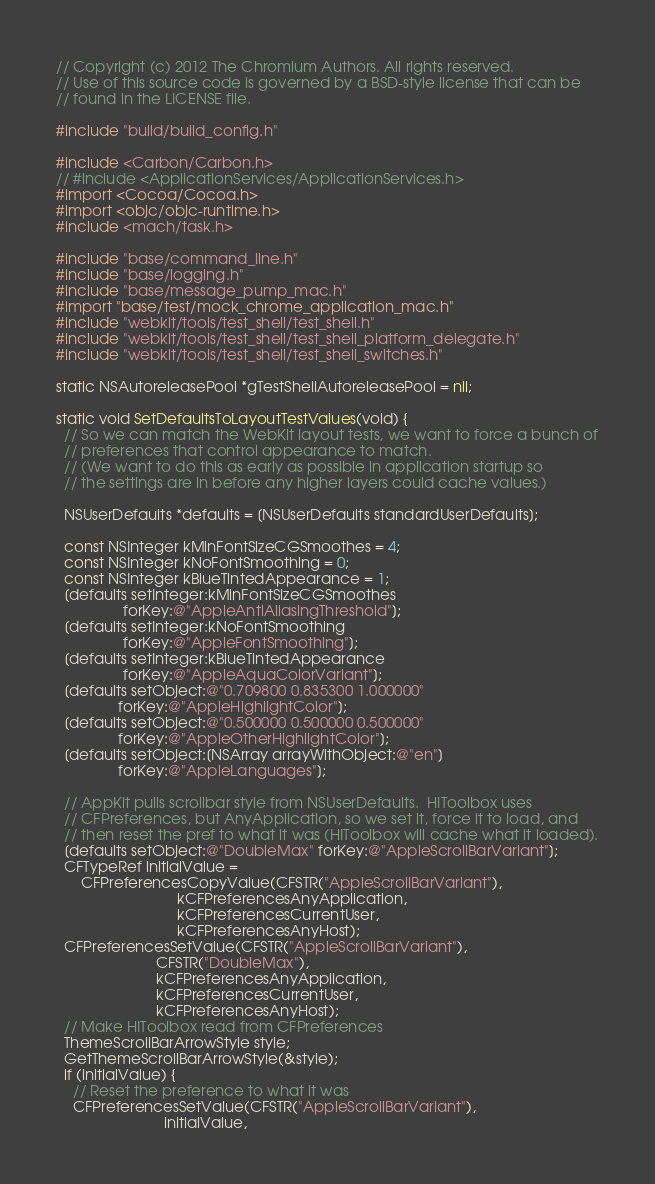<code> <loc_0><loc_0><loc_500><loc_500><_ObjectiveC_>// Copyright (c) 2012 The Chromium Authors. All rights reserved.
// Use of this source code is governed by a BSD-style license that can be
// found in the LICENSE file.

#include "build/build_config.h"

#include <Carbon/Carbon.h>
// #include <ApplicationServices/ApplicationServices.h>
#import <Cocoa/Cocoa.h>
#import <objc/objc-runtime.h>
#include <mach/task.h>

#include "base/command_line.h"
#include "base/logging.h"
#include "base/message_pump_mac.h"
#import "base/test/mock_chrome_application_mac.h"
#include "webkit/tools/test_shell/test_shell.h"
#include "webkit/tools/test_shell/test_shell_platform_delegate.h"
#include "webkit/tools/test_shell/test_shell_switches.h"

static NSAutoreleasePool *gTestShellAutoreleasePool = nil;

static void SetDefaultsToLayoutTestValues(void) {
  // So we can match the WebKit layout tests, we want to force a bunch of
  // preferences that control appearance to match.
  // (We want to do this as early as possible in application startup so
  // the settings are in before any higher layers could cache values.)

  NSUserDefaults *defaults = [NSUserDefaults standardUserDefaults];

  const NSInteger kMinFontSizeCGSmoothes = 4;
  const NSInteger kNoFontSmoothing = 0;
  const NSInteger kBlueTintedAppearance = 1;
  [defaults setInteger:kMinFontSizeCGSmoothes
                forKey:@"AppleAntiAliasingThreshold"];
  [defaults setInteger:kNoFontSmoothing
                forKey:@"AppleFontSmoothing"];
  [defaults setInteger:kBlueTintedAppearance
                forKey:@"AppleAquaColorVariant"];
  [defaults setObject:@"0.709800 0.835300 1.000000"
               forKey:@"AppleHighlightColor"];
  [defaults setObject:@"0.500000 0.500000 0.500000"
               forKey:@"AppleOtherHighlightColor"];
  [defaults setObject:[NSArray arrayWithObject:@"en"]
               forKey:@"AppleLanguages"];

  // AppKit pulls scrollbar style from NSUserDefaults.  HIToolbox uses
  // CFPreferences, but AnyApplication, so we set it, force it to load, and
  // then reset the pref to what it was (HIToolbox will cache what it loaded).
  [defaults setObject:@"DoubleMax" forKey:@"AppleScrollBarVariant"];
  CFTypeRef initialValue =
      CFPreferencesCopyValue(CFSTR("AppleScrollBarVariant"),
                             kCFPreferencesAnyApplication,
                             kCFPreferencesCurrentUser,
                             kCFPreferencesAnyHost);
  CFPreferencesSetValue(CFSTR("AppleScrollBarVariant"),
                        CFSTR("DoubleMax"),
                        kCFPreferencesAnyApplication,
                        kCFPreferencesCurrentUser,
                        kCFPreferencesAnyHost);
  // Make HIToolbox read from CFPreferences
  ThemeScrollBarArrowStyle style;
  GetThemeScrollBarArrowStyle(&style);
  if (initialValue) {
    // Reset the preference to what it was
    CFPreferencesSetValue(CFSTR("AppleScrollBarVariant"),
                          initialValue,</code> 